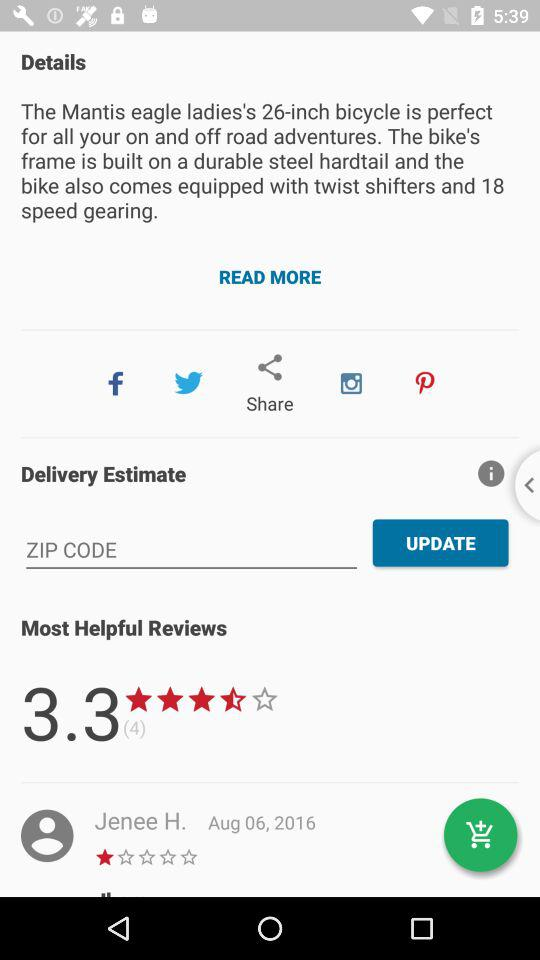Through which application can it be shared? It can be shared through "Facebook", "Twitter", "Instagram" and "Pinterest". 